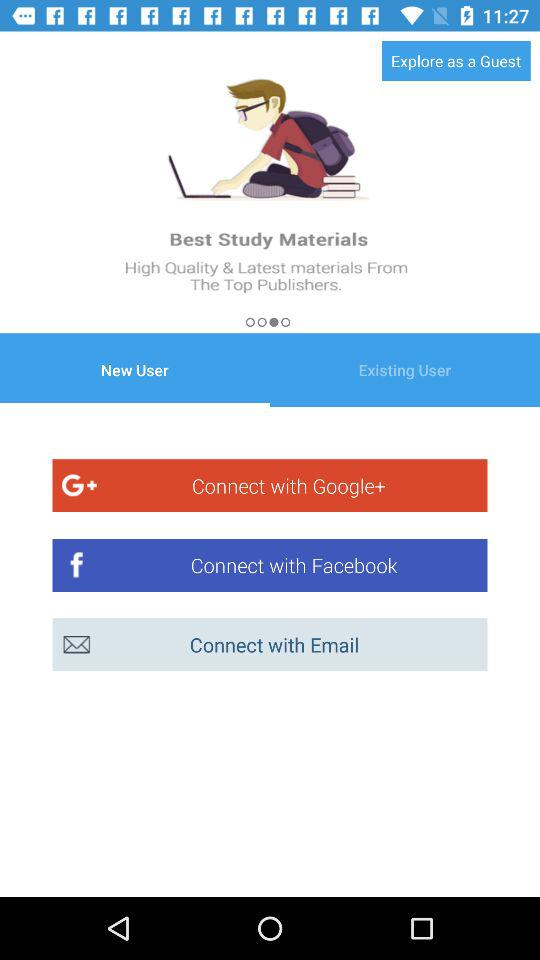Which account can I use to connect? The accounts that you can use to connect are "Google+", "Facebook" and "Email". 